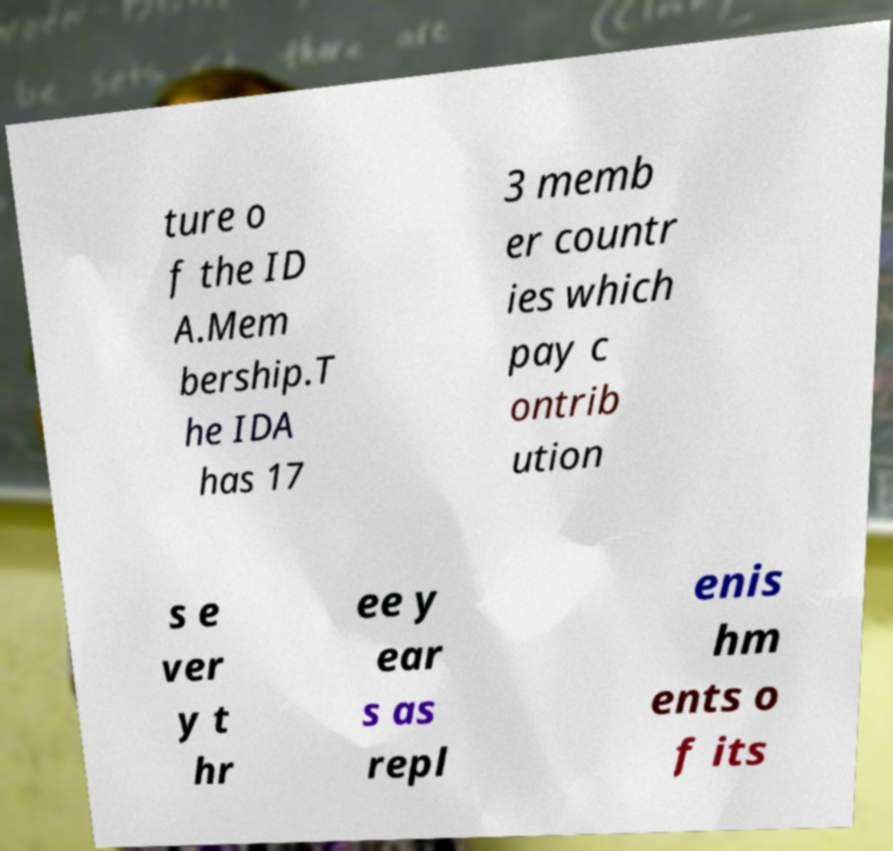Please read and relay the text visible in this image. What does it say? ture o f the ID A.Mem bership.T he IDA has 17 3 memb er countr ies which pay c ontrib ution s e ver y t hr ee y ear s as repl enis hm ents o f its 